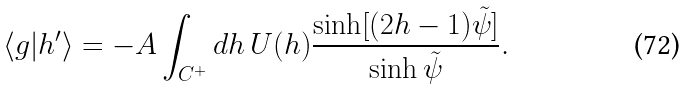Convert formula to latex. <formula><loc_0><loc_0><loc_500><loc_500>\langle g | h ^ { \prime } \rangle = - A \int _ { C ^ { + } } d h \, U ( h ) \frac { \sinh [ ( 2 h - 1 ) { \tilde { \psi } } ] } { \sinh { \tilde { \psi } } } .</formula> 